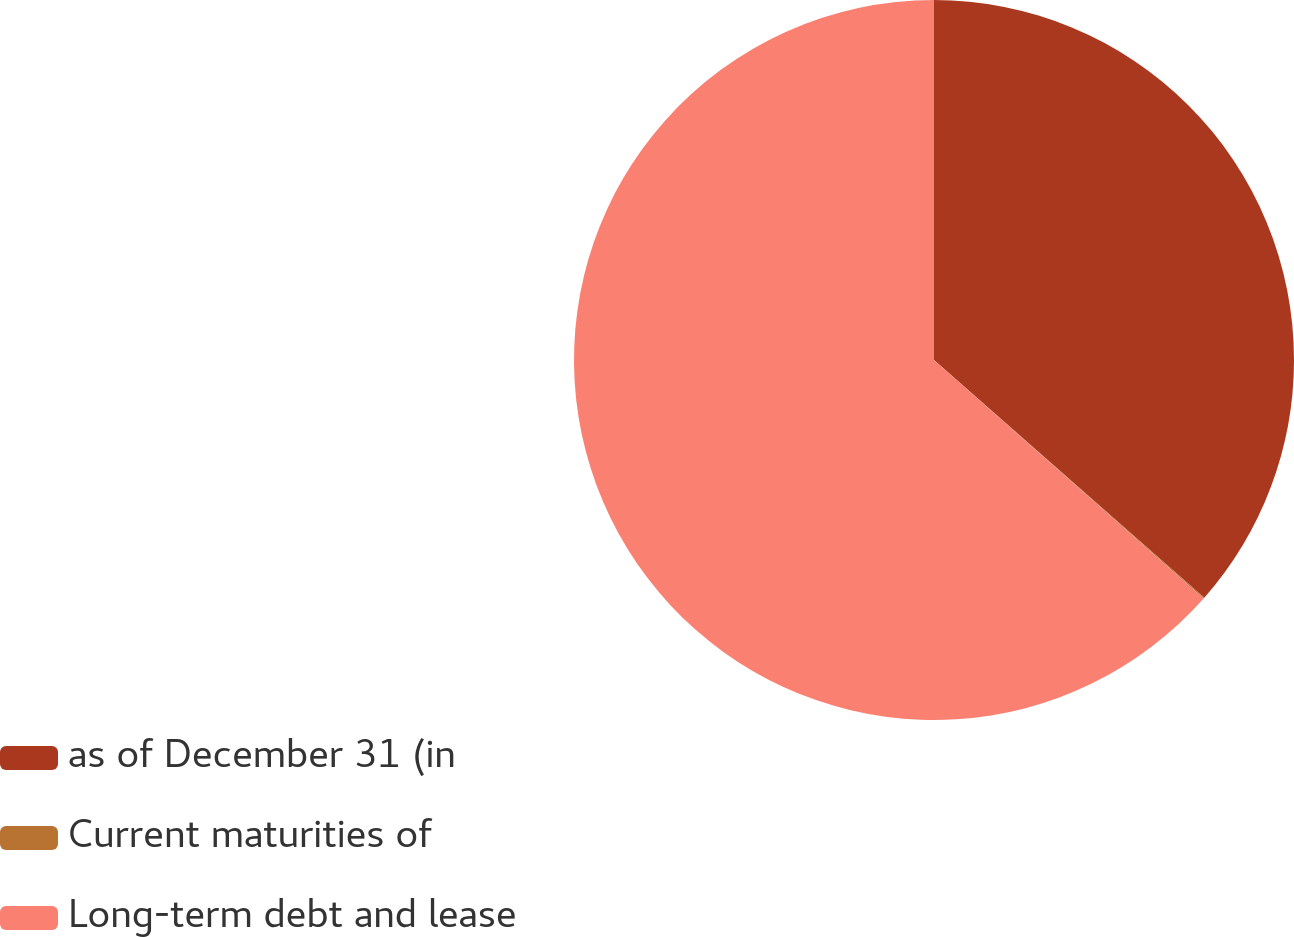Convert chart to OTSL. <chart><loc_0><loc_0><loc_500><loc_500><pie_chart><fcel>as of December 31 (in<fcel>Current maturities of<fcel>Long-term debt and lease<nl><fcel>36.48%<fcel>0.05%<fcel>63.47%<nl></chart> 